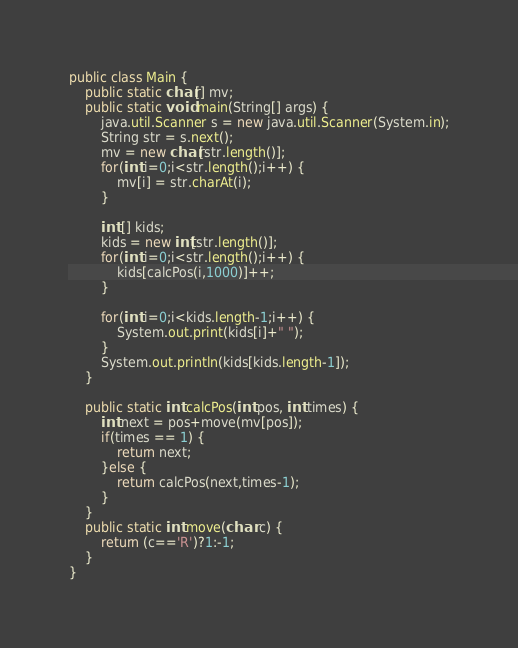Convert code to text. <code><loc_0><loc_0><loc_500><loc_500><_Java_>public class Main {
	public static char[] mv;
	public static void main(String[] args) {
		java.util.Scanner s = new java.util.Scanner(System.in);
		String str = s.next();
		mv = new char[str.length()];
		for(int i=0;i<str.length();i++) {
			mv[i] = str.charAt(i);
		}

		int [] kids;
		kids = new int[str.length()];
		for(int i=0;i<str.length();i++) {
			kids[calcPos(i,1000)]++;
		}

		for(int i=0;i<kids.length-1;i++) {
			System.out.print(kids[i]+" ");
		}
		System.out.println(kids[kids.length-1]);
	}

	public static int calcPos(int pos, int times) {
		int next = pos+move(mv[pos]);
		if(times == 1) {
			return next;
		}else {
			return calcPos(next,times-1);
		}
	}
	public static int move(char c) {
		return (c=='R')?1:-1;
	}
}
</code> 